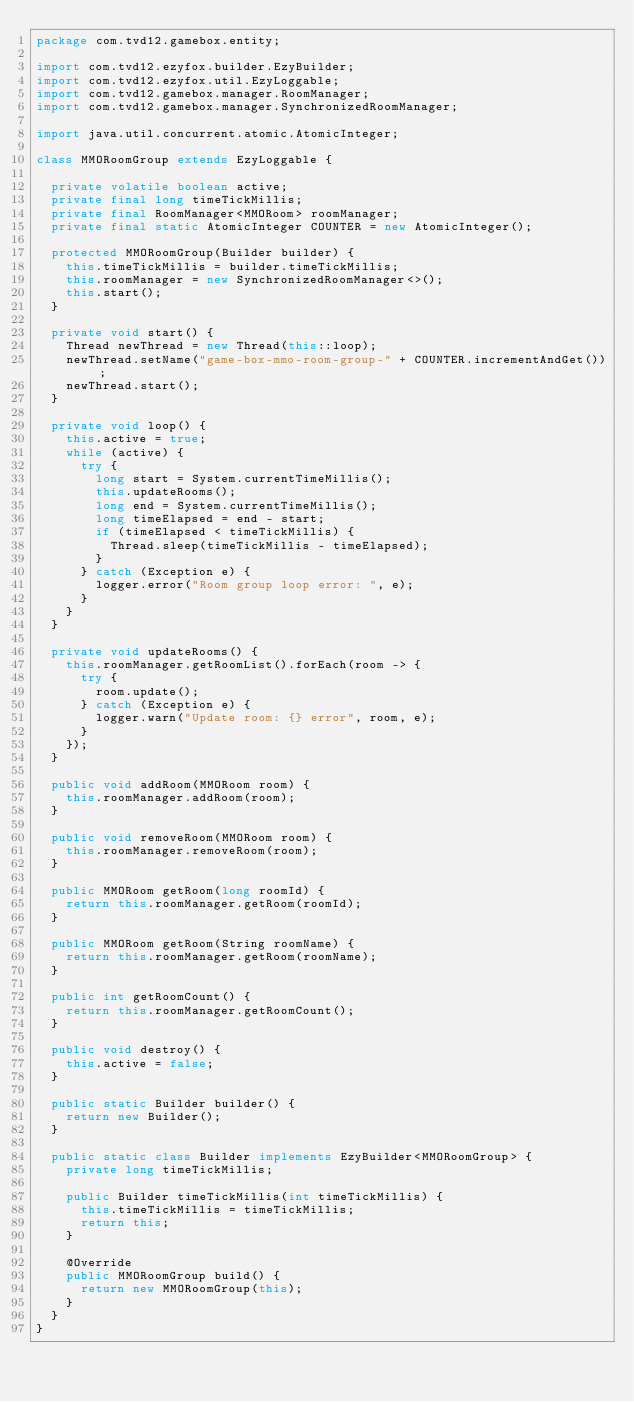Convert code to text. <code><loc_0><loc_0><loc_500><loc_500><_Java_>package com.tvd12.gamebox.entity;

import com.tvd12.ezyfox.builder.EzyBuilder;
import com.tvd12.ezyfox.util.EzyLoggable;
import com.tvd12.gamebox.manager.RoomManager;
import com.tvd12.gamebox.manager.SynchronizedRoomManager;

import java.util.concurrent.atomic.AtomicInteger;

class MMORoomGroup extends EzyLoggable {
	
	private volatile boolean active;
	private final long timeTickMillis;
	private final RoomManager<MMORoom> roomManager;
	private final static AtomicInteger COUNTER = new AtomicInteger();
	
	protected MMORoomGroup(Builder builder) {
		this.timeTickMillis = builder.timeTickMillis;
		this.roomManager = new SynchronizedRoomManager<>();
		this.start();
	}
	
	private void start() {
		Thread newThread = new Thread(this::loop);
		newThread.setName("game-box-mmo-room-group-" + COUNTER.incrementAndGet());
		newThread.start();
	}
	
	private void loop() {
		this.active = true;
		while (active) {
			try {
				long start = System.currentTimeMillis();
				this.updateRooms();
				long end = System.currentTimeMillis();
				long timeElapsed = end - start;
				if (timeElapsed < timeTickMillis) {
					Thread.sleep(timeTickMillis - timeElapsed);
				}
			} catch (Exception e) {
				logger.error("Room group loop error: ", e);
			}
		}
	}
	
	private void updateRooms() {
		this.roomManager.getRoomList().forEach(room -> {
			try {
				room.update();
			} catch (Exception e) {
				logger.warn("Update room: {} error", room, e);
			}
		});
	}
	
	public void addRoom(MMORoom room) {
		this.roomManager.addRoom(room);
	}
	
	public void removeRoom(MMORoom room) {
		this.roomManager.removeRoom(room);
	}
	
	public MMORoom getRoom(long roomId) {
		return this.roomManager.getRoom(roomId);
	}
	
	public MMORoom getRoom(String roomName) {
		return this.roomManager.getRoom(roomName);
	}
	
	public int getRoomCount() {
		return this.roomManager.getRoomCount();
	}
	
	public void destroy() {
		this.active = false;
	}
	
	public static Builder builder() {
		return new Builder();
	}
	
	public static class Builder implements EzyBuilder<MMORoomGroup> {
		private long timeTickMillis;
		
		public Builder timeTickMillis(int timeTickMillis) {
			this.timeTickMillis = timeTickMillis;
			return this;
		}
		
		@Override
		public MMORoomGroup build() {
			return new MMORoomGroup(this);
		}
	}
}
</code> 